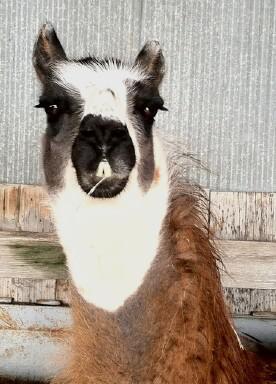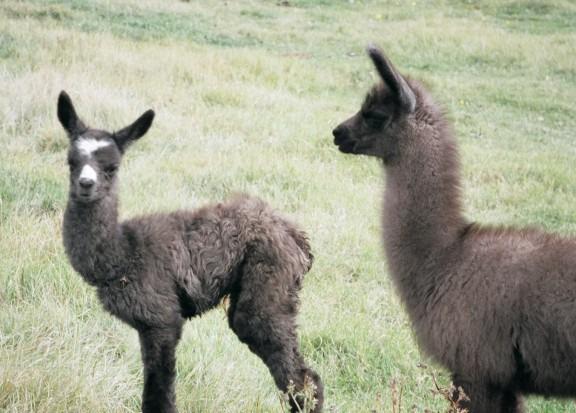The first image is the image on the left, the second image is the image on the right. Considering the images on both sides, is "There are two llamas in the left image and one llama in the right image." valid? Answer yes or no. No. 